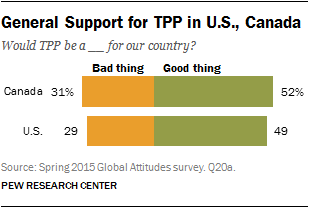Identify some key points in this picture. In a recent decision, a total of 60% of Canada and the United States have decided that "Top" is a bad thing. The two bars in the chart represent a bad thing and a good thing. 